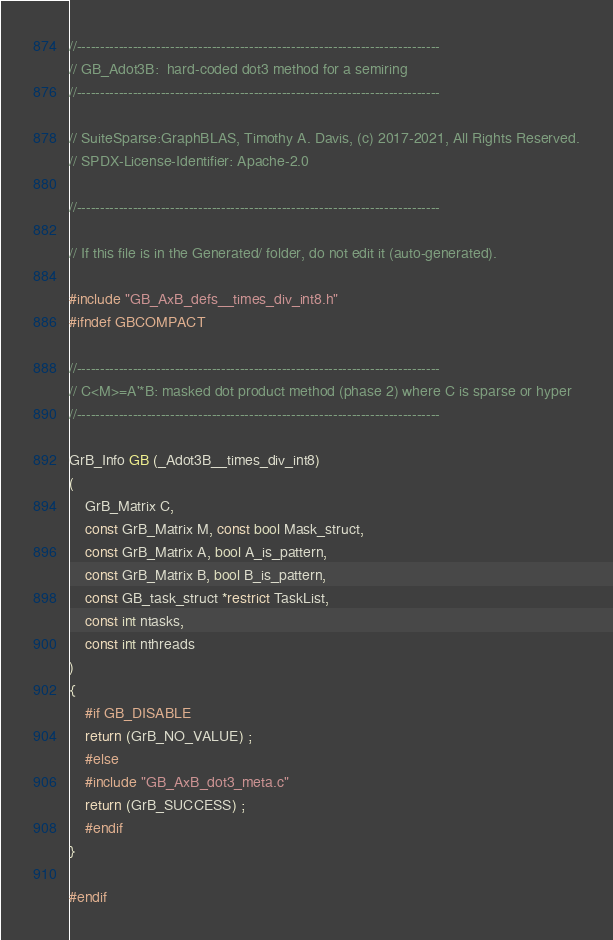<code> <loc_0><loc_0><loc_500><loc_500><_C_>//------------------------------------------------------------------------------
// GB_Adot3B:  hard-coded dot3 method for a semiring
//------------------------------------------------------------------------------

// SuiteSparse:GraphBLAS, Timothy A. Davis, (c) 2017-2021, All Rights Reserved.
// SPDX-License-Identifier: Apache-2.0

//------------------------------------------------------------------------------

// If this file is in the Generated/ folder, do not edit it (auto-generated).

#include "GB_AxB_defs__times_div_int8.h"
#ifndef GBCOMPACT

//------------------------------------------------------------------------------
// C<M>=A'*B: masked dot product method (phase 2) where C is sparse or hyper
//------------------------------------------------------------------------------

GrB_Info GB (_Adot3B__times_div_int8)
(
    GrB_Matrix C,
    const GrB_Matrix M, const bool Mask_struct,
    const GrB_Matrix A, bool A_is_pattern,
    const GrB_Matrix B, bool B_is_pattern,
    const GB_task_struct *restrict TaskList,
    const int ntasks,
    const int nthreads
)
{ 
    #if GB_DISABLE
    return (GrB_NO_VALUE) ;
    #else
    #include "GB_AxB_dot3_meta.c"
    return (GrB_SUCCESS) ;
    #endif
}

#endif

</code> 